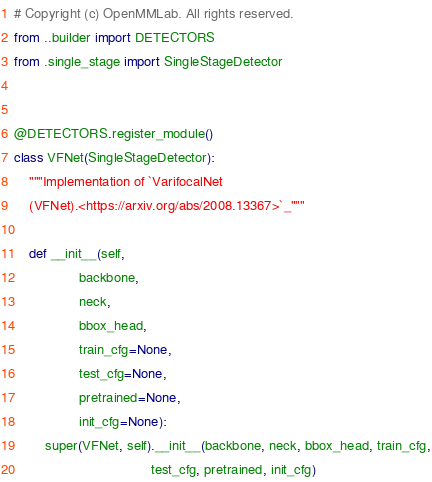<code> <loc_0><loc_0><loc_500><loc_500><_Python_># Copyright (c) OpenMMLab. All rights reserved.
from ..builder import DETECTORS
from .single_stage import SingleStageDetector


@DETECTORS.register_module()
class VFNet(SingleStageDetector):
    """Implementation of `VarifocalNet
    (VFNet).<https://arxiv.org/abs/2008.13367>`_"""

    def __init__(self,
                 backbone,
                 neck,
                 bbox_head,
                 train_cfg=None,
                 test_cfg=None,
                 pretrained=None,
                 init_cfg=None):
        super(VFNet, self).__init__(backbone, neck, bbox_head, train_cfg,
                                    test_cfg, pretrained, init_cfg)
</code> 